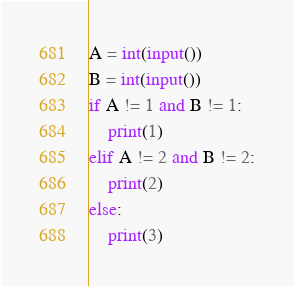<code> <loc_0><loc_0><loc_500><loc_500><_Python_>
A = int(input())
B = int(input())
if A != 1 and B != 1:
    print(1)
elif A != 2 and B != 2:
    print(2)
else:
    print(3)</code> 